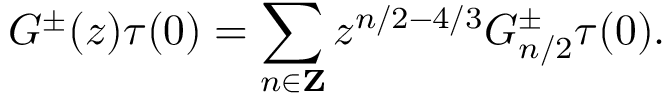Convert formula to latex. <formula><loc_0><loc_0><loc_500><loc_500>G ^ { \pm } ( z ) \tau ( 0 ) = \sum _ { n \in { Z } } z ^ { n / 2 - 4 / 3 } G _ { n / 2 } ^ { \pm } \tau ( 0 ) .</formula> 